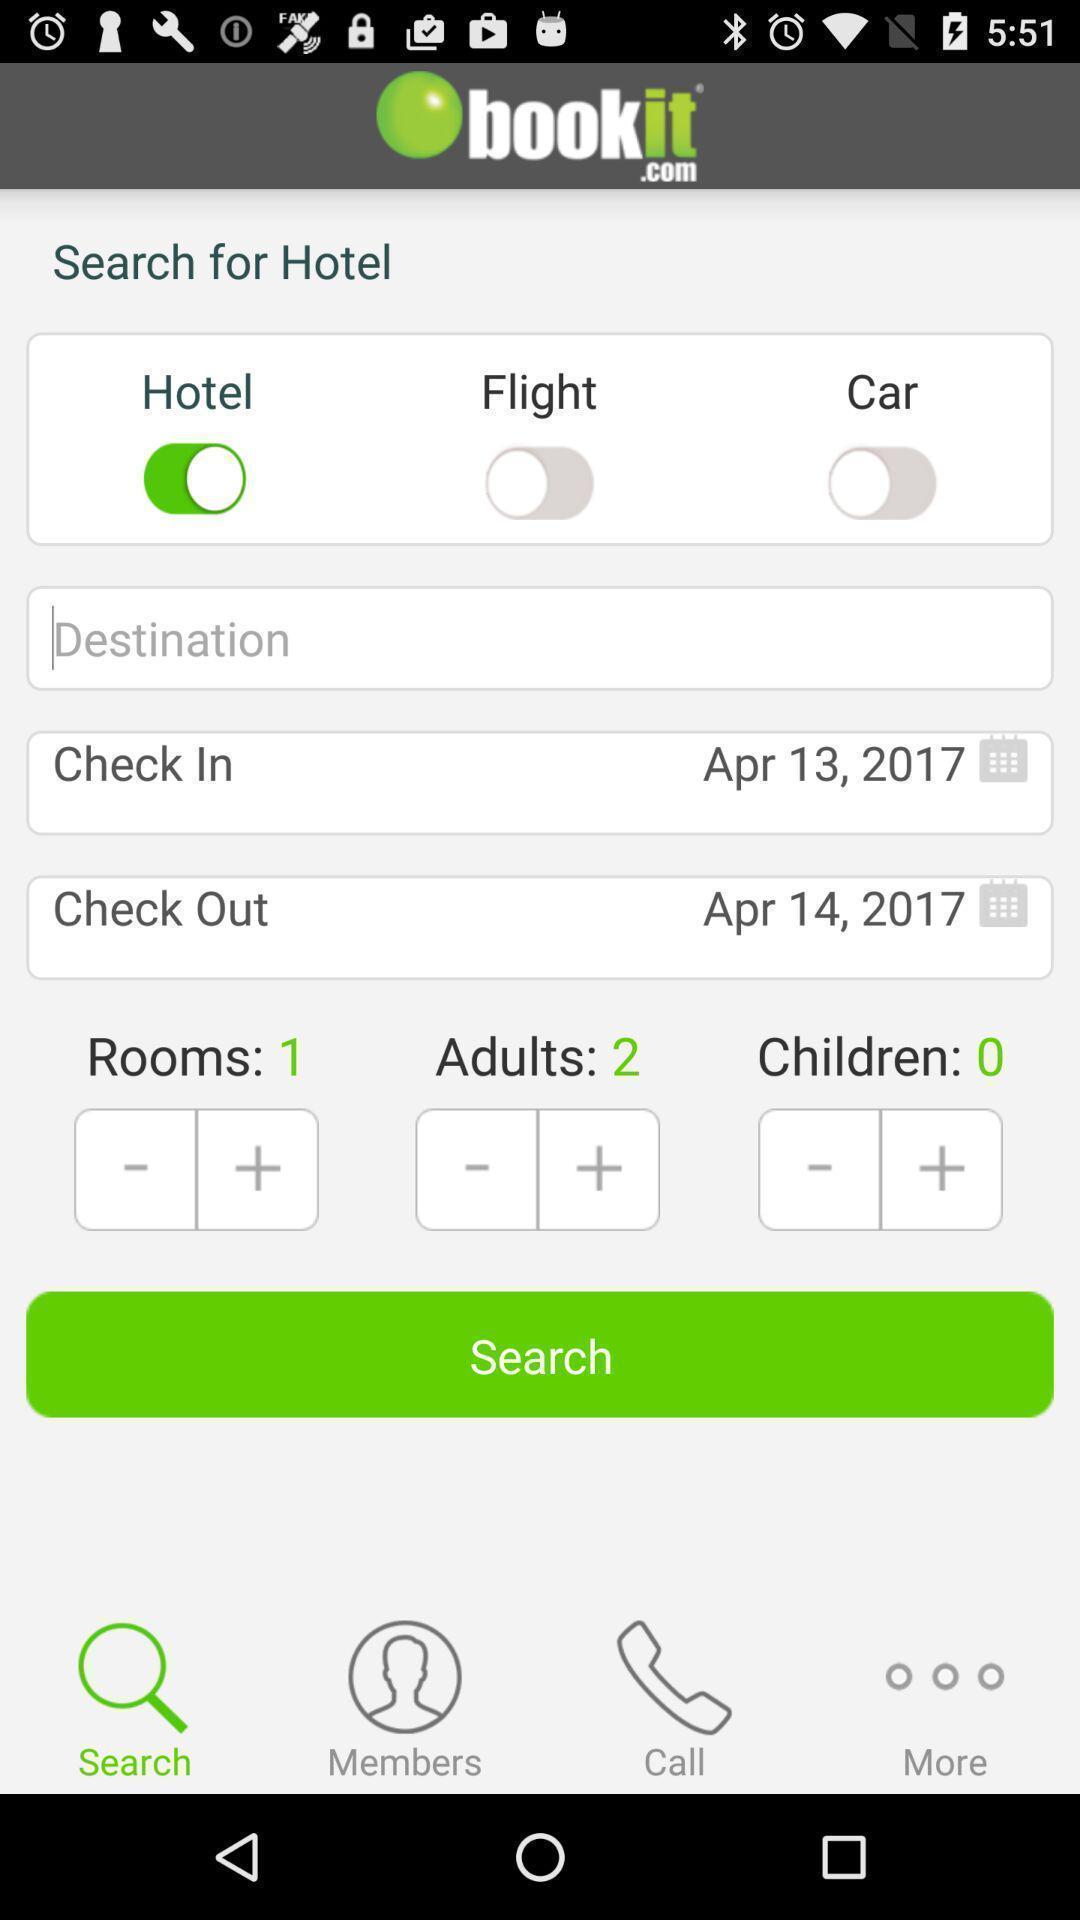Explain what's happening in this screen capture. Search page for finding hotels on booking app. 